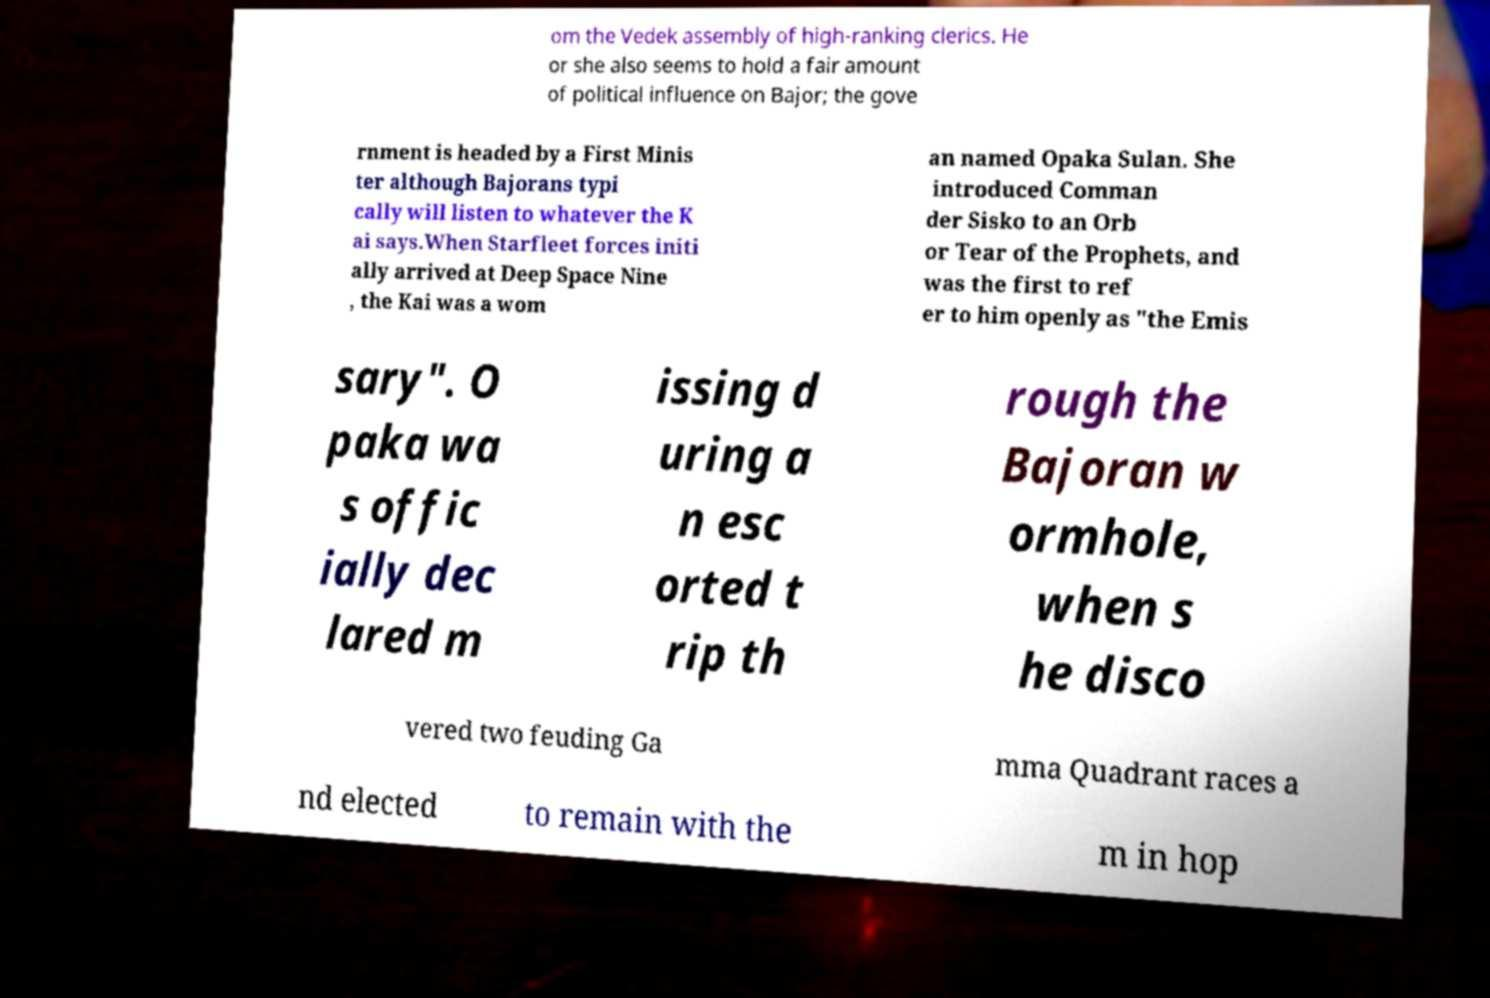I need the written content from this picture converted into text. Can you do that? om the Vedek assembly of high-ranking clerics. He or she also seems to hold a fair amount of political influence on Bajor; the gove rnment is headed by a First Minis ter although Bajorans typi cally will listen to whatever the K ai says.When Starfleet forces initi ally arrived at Deep Space Nine , the Kai was a wom an named Opaka Sulan. She introduced Comman der Sisko to an Orb or Tear of the Prophets, and was the first to ref er to him openly as "the Emis sary". O paka wa s offic ially dec lared m issing d uring a n esc orted t rip th rough the Bajoran w ormhole, when s he disco vered two feuding Ga mma Quadrant races a nd elected to remain with the m in hop 